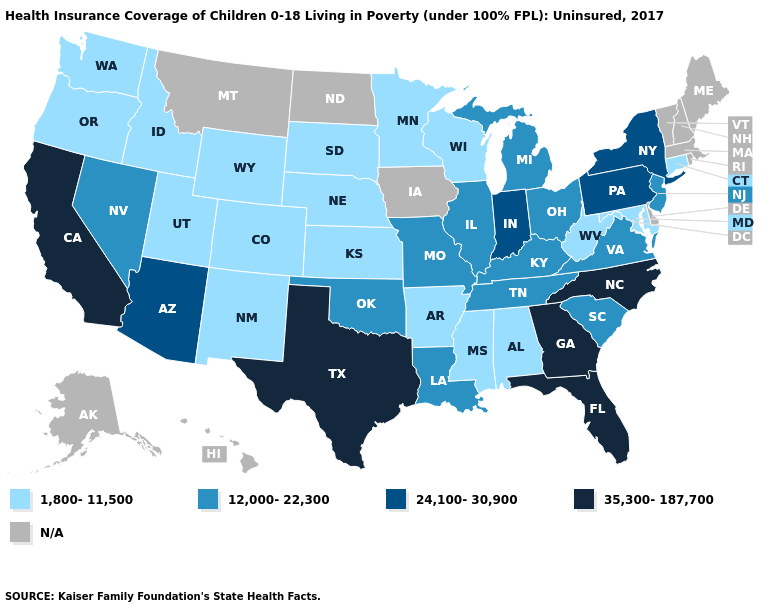Which states have the lowest value in the USA?
Give a very brief answer. Alabama, Arkansas, Colorado, Connecticut, Idaho, Kansas, Maryland, Minnesota, Mississippi, Nebraska, New Mexico, Oregon, South Dakota, Utah, Washington, West Virginia, Wisconsin, Wyoming. How many symbols are there in the legend?
Give a very brief answer. 5. What is the value of New Hampshire?
Give a very brief answer. N/A. Does the first symbol in the legend represent the smallest category?
Give a very brief answer. Yes. Which states hav the highest value in the MidWest?
Give a very brief answer. Indiana. Among the states that border Maryland , does Pennsylvania have the highest value?
Short answer required. Yes. What is the lowest value in states that border Georgia?
Short answer required. 1,800-11,500. Name the states that have a value in the range 12,000-22,300?
Quick response, please. Illinois, Kentucky, Louisiana, Michigan, Missouri, Nevada, New Jersey, Ohio, Oklahoma, South Carolina, Tennessee, Virginia. What is the highest value in the USA?
Short answer required. 35,300-187,700. Does Florida have the lowest value in the USA?
Answer briefly. No. Is the legend a continuous bar?
Answer briefly. No. What is the lowest value in the USA?
Quick response, please. 1,800-11,500. Name the states that have a value in the range 24,100-30,900?
Answer briefly. Arizona, Indiana, New York, Pennsylvania. 